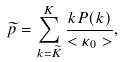Convert formula to latex. <formula><loc_0><loc_0><loc_500><loc_500>\widetilde { p } = \sum _ { k = \widetilde { K } } ^ { K } \frac { k P ( k ) } { < \kappa _ { 0 } > } ,</formula> 